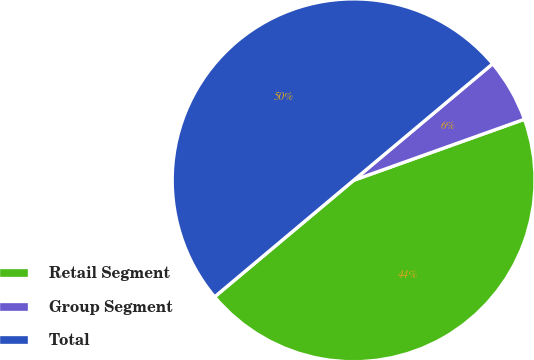<chart> <loc_0><loc_0><loc_500><loc_500><pie_chart><fcel>Retail Segment<fcel>Group Segment<fcel>Total<nl><fcel>44.36%<fcel>5.64%<fcel>50.0%<nl></chart> 